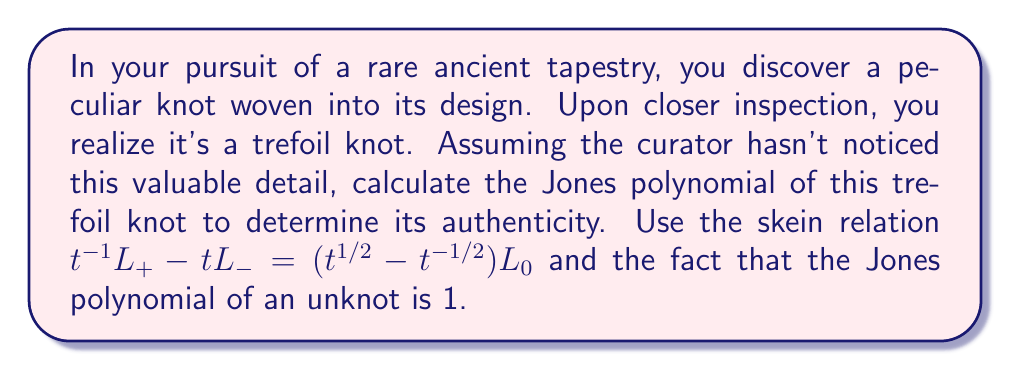What is the answer to this math problem? To calculate the Jones polynomial of the trefoil knot, we'll use the skein relation and work step-by-step:

1) First, we need to consider the trefoil knot and its related diagrams:
   - $L_+$ is the original trefoil knot
   - $L_-$ is the diagram where one crossing is changed
   - $L_0$ is the diagram where that crossing is removed

2) Applying the skein relation:
   $$t^{-1}L_+ - tL_- = (t^{1/2} - t^{-1/2})L_0$$

3) $L_-$ in this case is an unknot, so its Jones polynomial is 1.
   $L_0$ is a two-component unlink, which has a Jones polynomial of $-(t^{1/2} + t^{-1/2})$.

4) Substituting these into the skein relation:
   $$t^{-1}L_+ - t(1) = (t^{1/2} - t^{-1/2})(-(t^{1/2} + t^{-1/2}))$$

5) Expanding the right side:
   $$t^{-1}L_+ - t = -t - t^{-1} + t^0 + t^{-2}$$

6) Solving for $L_+$ (the trefoil knot):
   $$L_+ = t(-t - t^{-1} + 1 + t^{-2}) + t^2$$

7) Simplifying:
   $$L_+ = -t^2 - 1 + t + t^{-1} + t^2 = t + t^{-1} - 1$$

Therefore, the Jones polynomial of the trefoil knot is $t + t^{-1} - 1$.
Answer: $t + t^{-1} - 1$ 